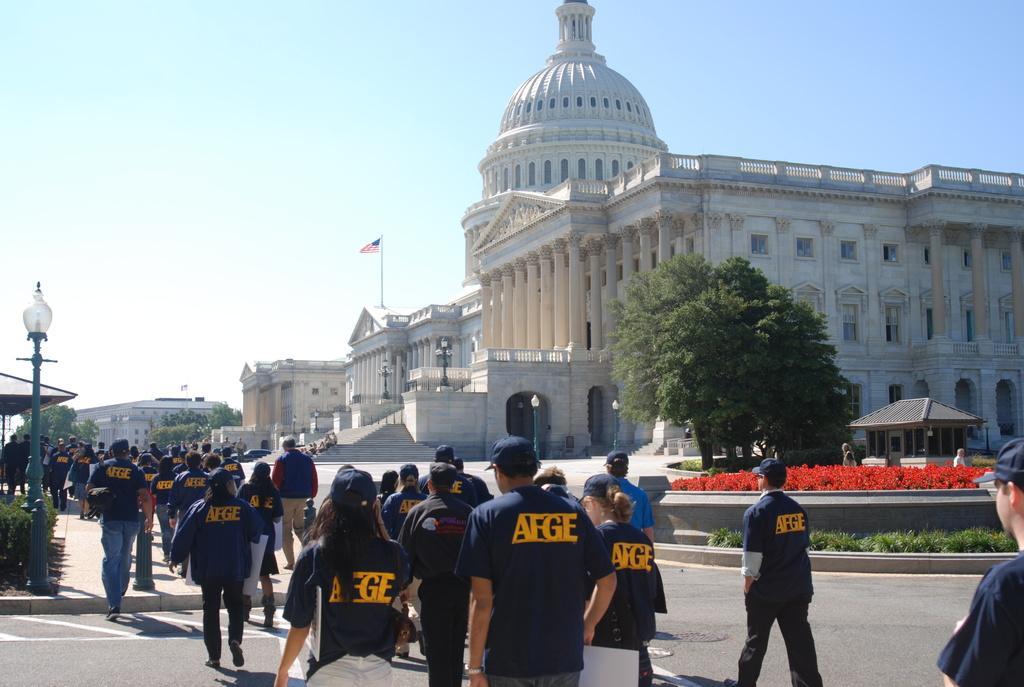How would you summarize this image in a sentence or two? In the image there are many people in navy blue t-shirts and caps walking on the road, it seems to be a rally, on the right side there is a palace with trees in front of it and above its sky. 